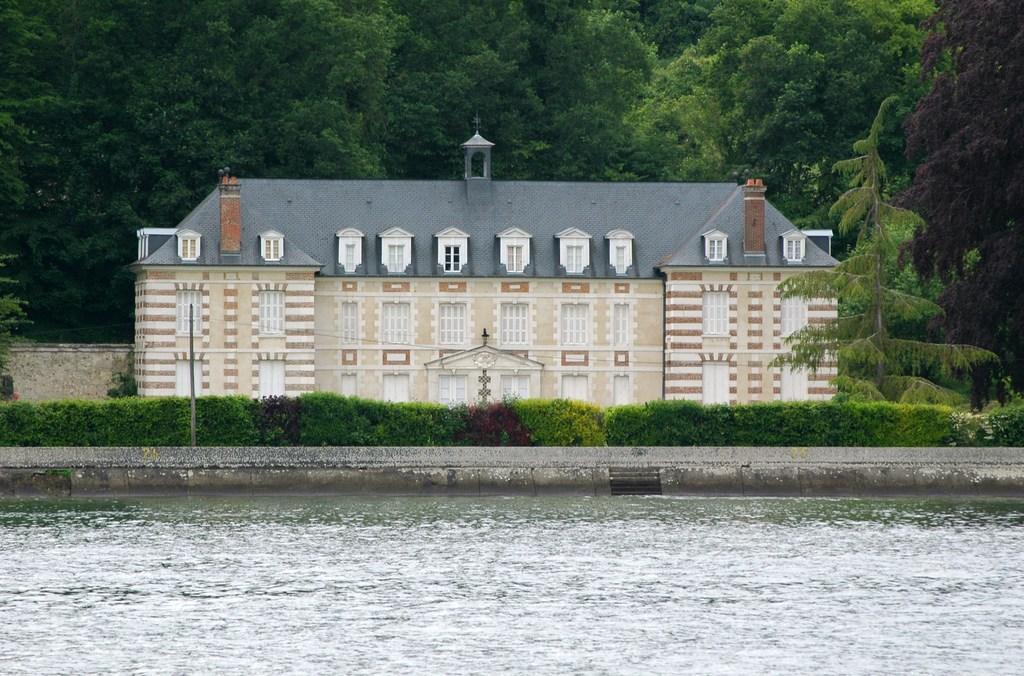Please provide a concise description of this image. In the foreground of the pictures there is water. In the center of the picture there are plants, trees and a building. In the background there are trees. 